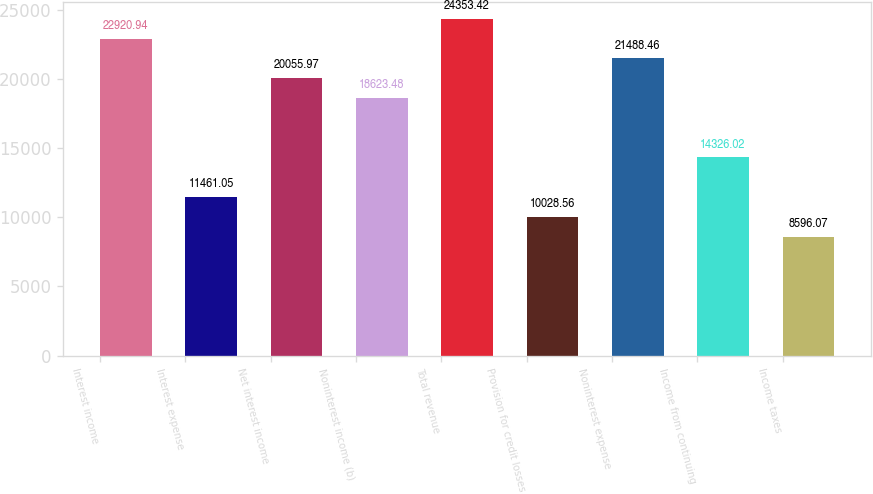Convert chart to OTSL. <chart><loc_0><loc_0><loc_500><loc_500><bar_chart><fcel>Interest income<fcel>Interest expense<fcel>Net interest income<fcel>Noninterest income (b)<fcel>Total revenue<fcel>Provision for credit losses<fcel>Noninterest expense<fcel>Income from continuing<fcel>Income taxes<nl><fcel>22920.9<fcel>11461<fcel>20056<fcel>18623.5<fcel>24353.4<fcel>10028.6<fcel>21488.5<fcel>14326<fcel>8596.07<nl></chart> 